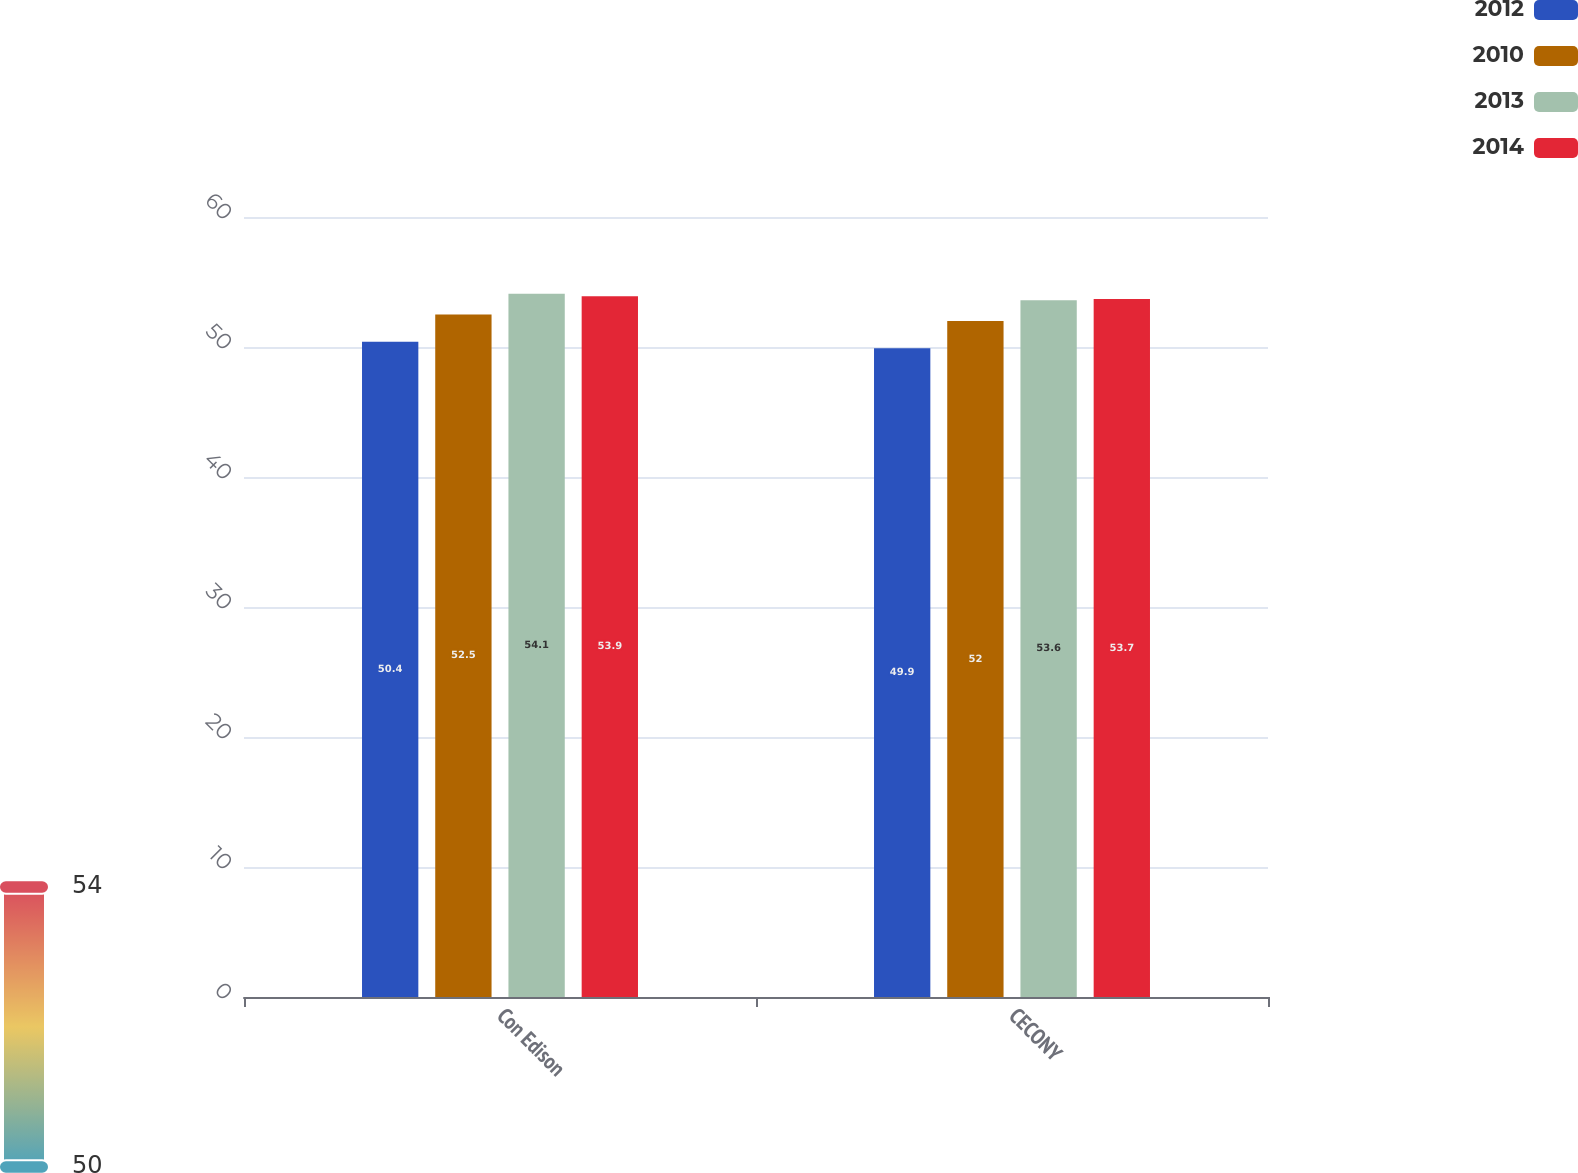<chart> <loc_0><loc_0><loc_500><loc_500><stacked_bar_chart><ecel><fcel>Con Edison<fcel>CECONY<nl><fcel>2012<fcel>50.4<fcel>49.9<nl><fcel>2010<fcel>52.5<fcel>52<nl><fcel>2013<fcel>54.1<fcel>53.6<nl><fcel>2014<fcel>53.9<fcel>53.7<nl></chart> 